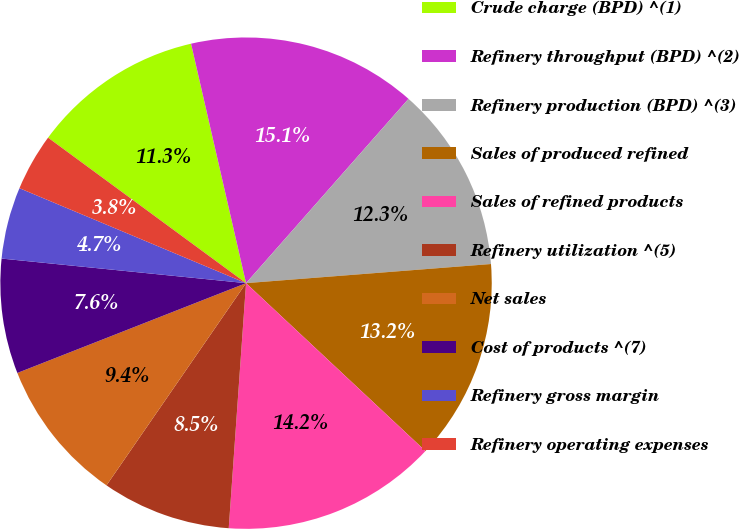Convert chart to OTSL. <chart><loc_0><loc_0><loc_500><loc_500><pie_chart><fcel>Crude charge (BPD) ^(1)<fcel>Refinery throughput (BPD) ^(2)<fcel>Refinery production (BPD) ^(3)<fcel>Sales of produced refined<fcel>Sales of refined products<fcel>Refinery utilization ^(5)<fcel>Net sales<fcel>Cost of products ^(7)<fcel>Refinery gross margin<fcel>Refinery operating expenses<nl><fcel>11.32%<fcel>15.09%<fcel>12.26%<fcel>13.21%<fcel>14.15%<fcel>8.49%<fcel>9.43%<fcel>7.55%<fcel>4.72%<fcel>3.77%<nl></chart> 